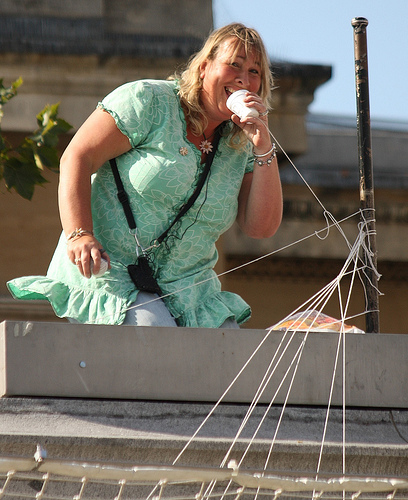<image>
Is there a woman on the building? Yes. Looking at the image, I can see the woman is positioned on top of the building, with the building providing support. 